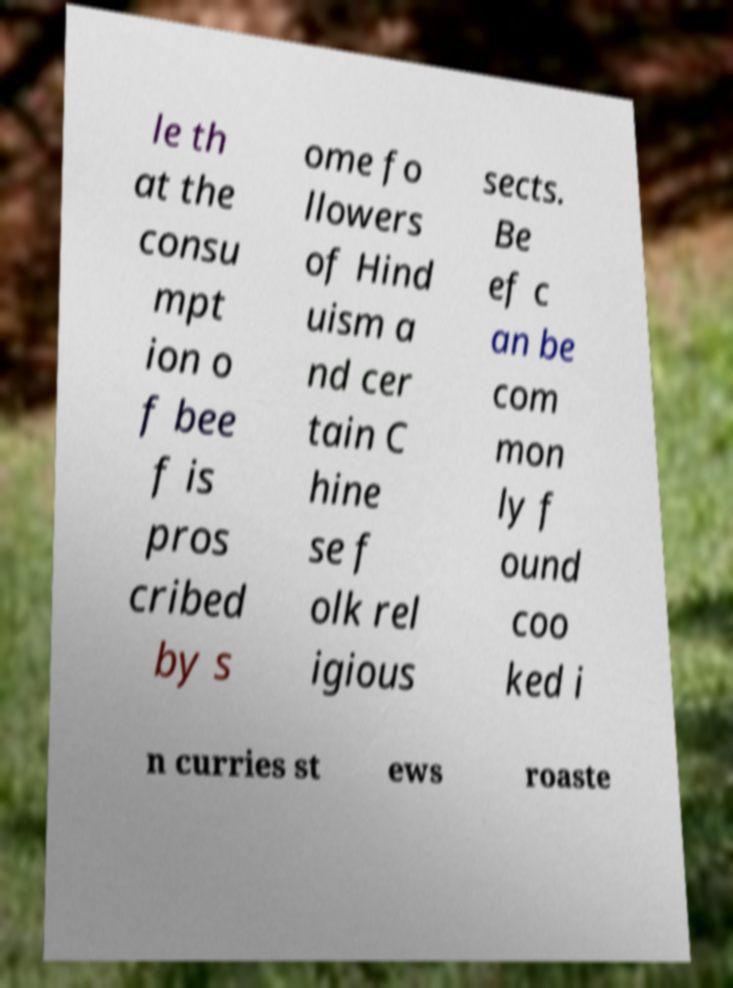There's text embedded in this image that I need extracted. Can you transcribe it verbatim? le th at the consu mpt ion o f bee f is pros cribed by s ome fo llowers of Hind uism a nd cer tain C hine se f olk rel igious sects. Be ef c an be com mon ly f ound coo ked i n curries st ews roaste 